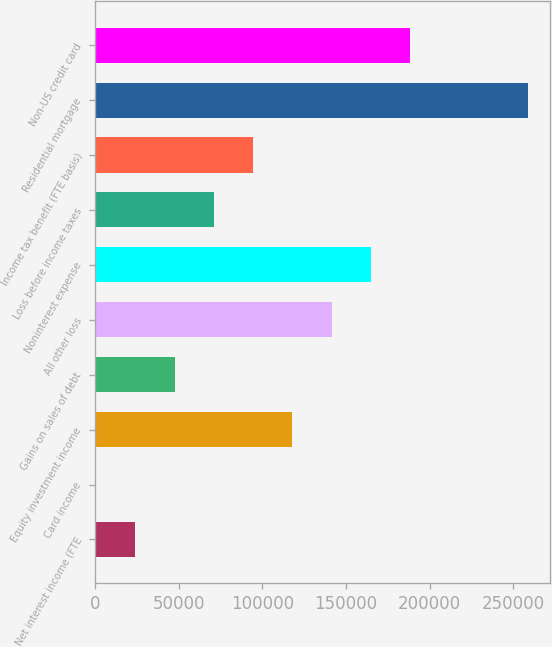Convert chart. <chart><loc_0><loc_0><loc_500><loc_500><bar_chart><fcel>Net interest income (FTE<fcel>Card income<fcel>Equity investment income<fcel>Gains on sales of debt<fcel>All other loss<fcel>Noninterest expense<fcel>Loss before income taxes<fcel>Income tax benefit (FTE basis)<fcel>Residential mortgage<fcel>Non-US credit card<nl><fcel>23840.6<fcel>328<fcel>117891<fcel>47353.2<fcel>141404<fcel>164916<fcel>70865.8<fcel>94378.4<fcel>258967<fcel>188429<nl></chart> 